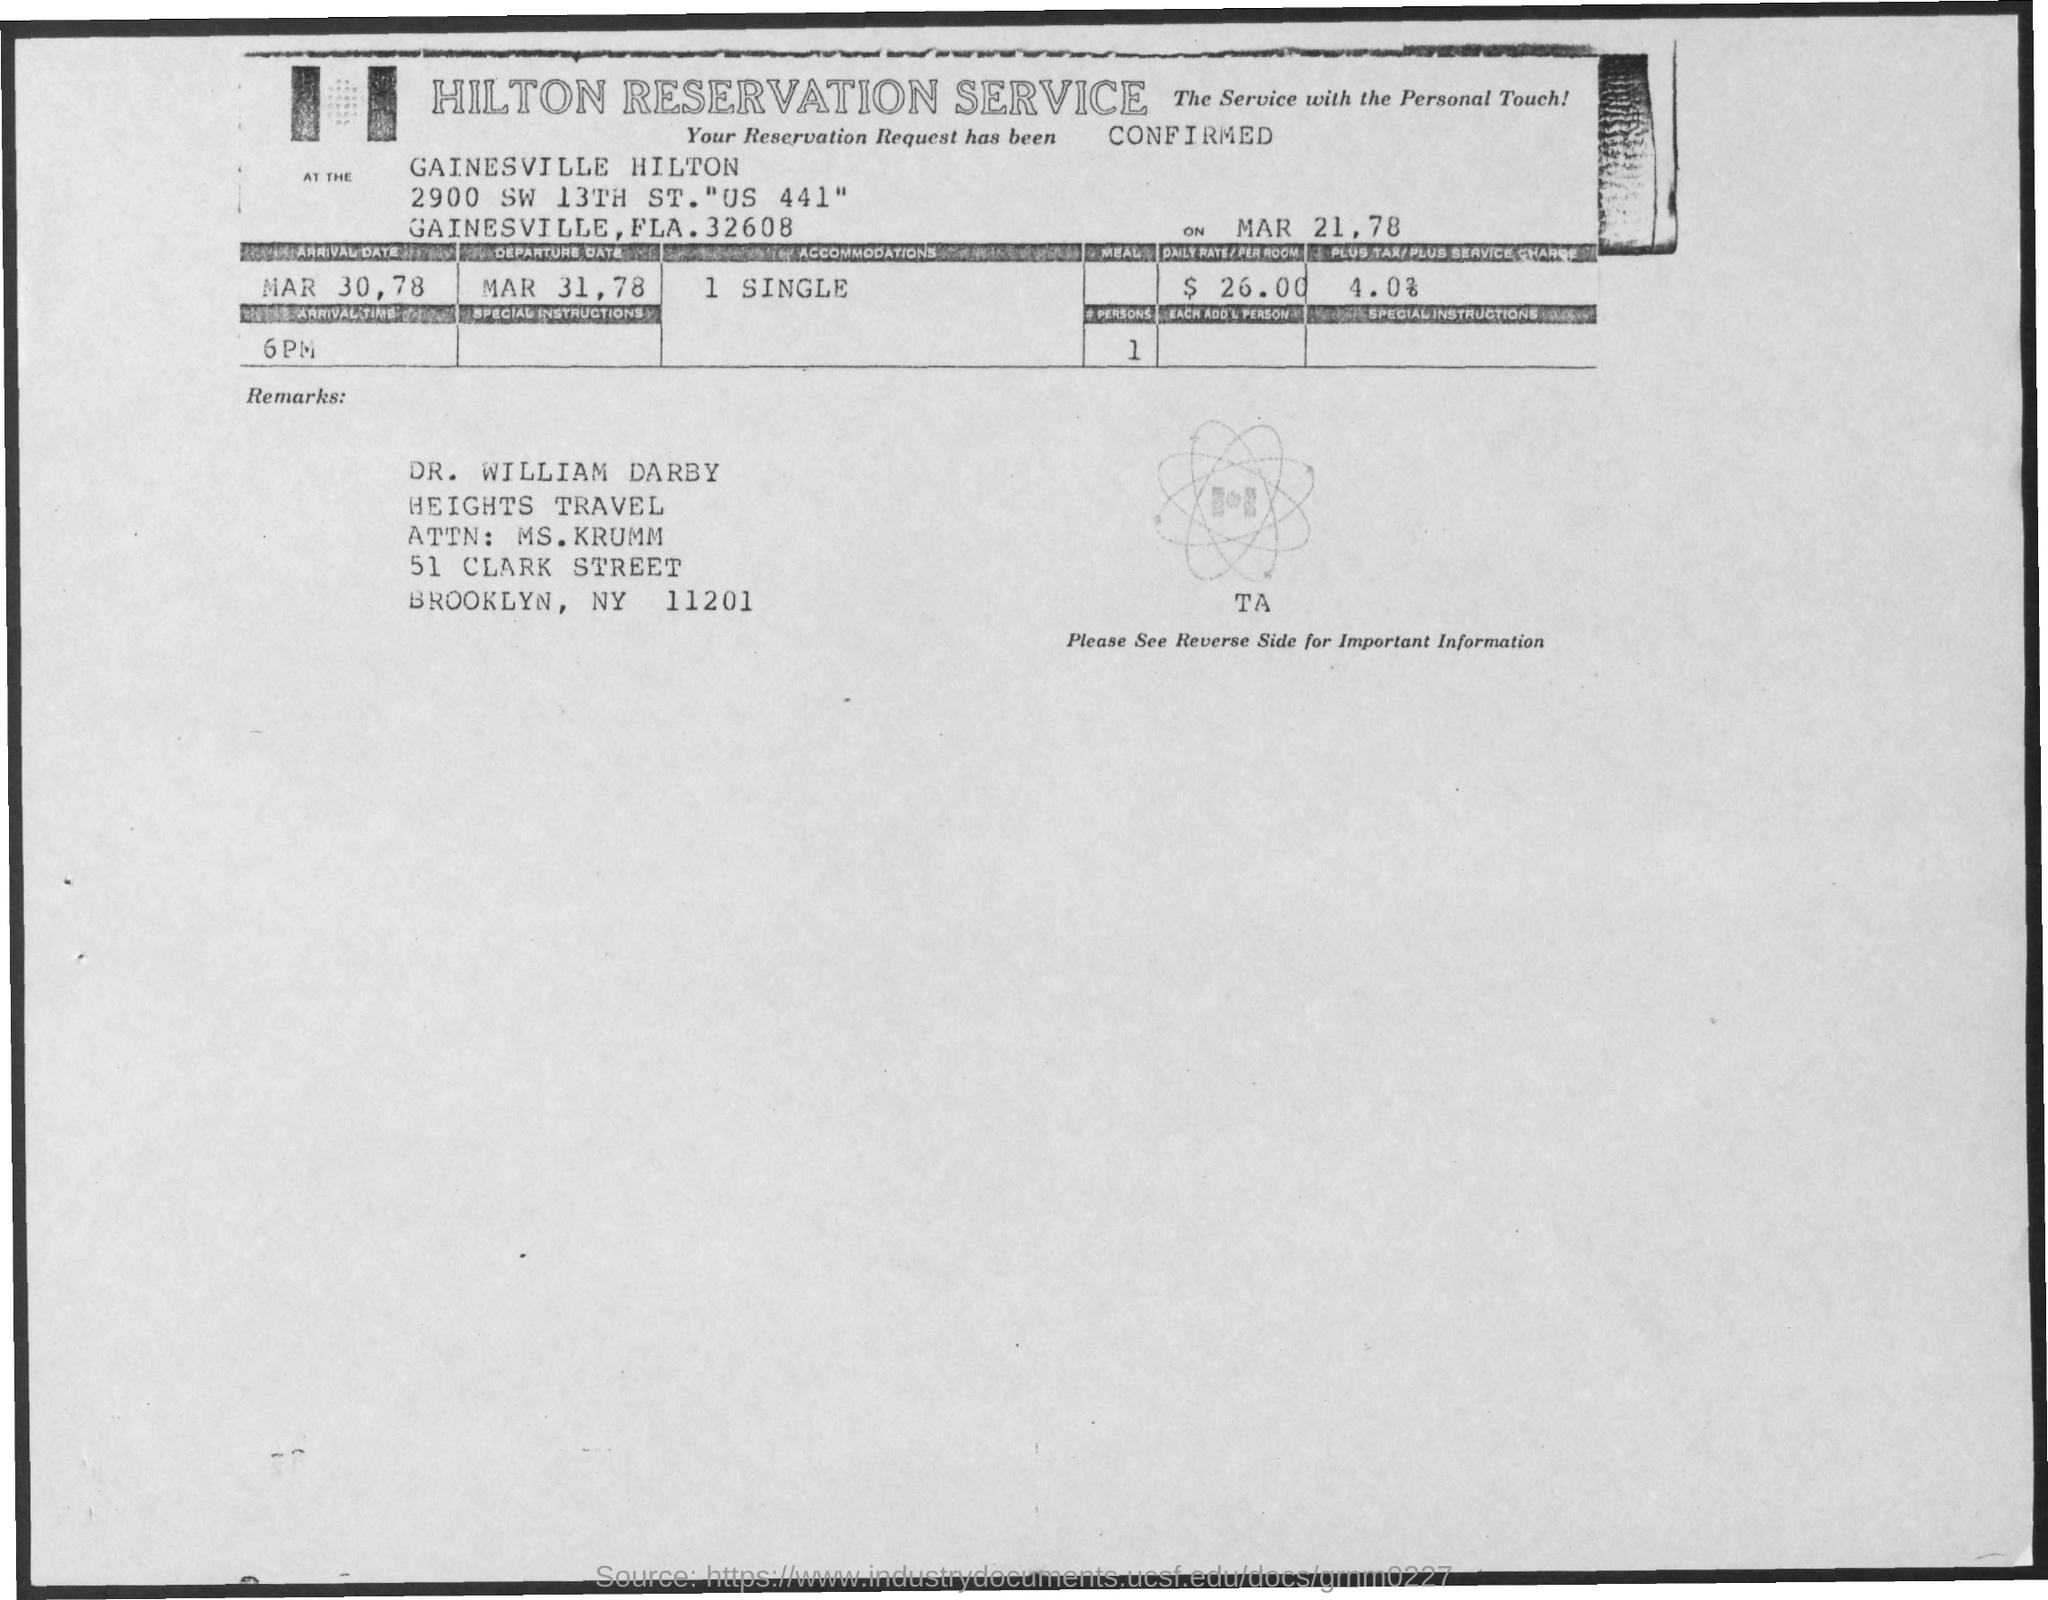What is the main title of the document?
Offer a terse response. Hilton Reservation Service. 